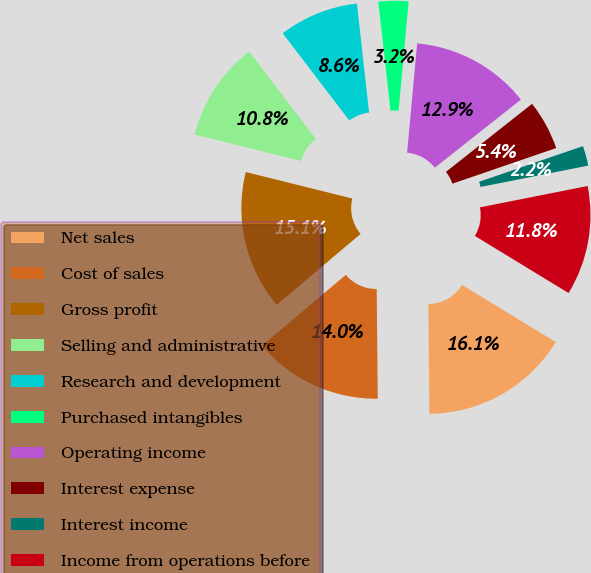Convert chart to OTSL. <chart><loc_0><loc_0><loc_500><loc_500><pie_chart><fcel>Net sales<fcel>Cost of sales<fcel>Gross profit<fcel>Selling and administrative<fcel>Research and development<fcel>Purchased intangibles<fcel>Operating income<fcel>Interest expense<fcel>Interest income<fcel>Income from operations before<nl><fcel>16.13%<fcel>13.98%<fcel>15.05%<fcel>10.75%<fcel>8.6%<fcel>3.23%<fcel>12.9%<fcel>5.38%<fcel>2.15%<fcel>11.83%<nl></chart> 